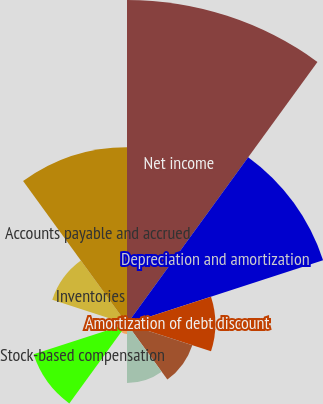Convert chart. <chart><loc_0><loc_0><loc_500><loc_500><pie_chart><fcel>Net income<fcel>Depreciation and amortization<fcel>Amortization of debt discount<fcel>Acquisition-related items<fcel>Provision for doubtful<fcel>Deferred income taxes<fcel>Stock-based compensation<fcel>Accounts receivable net<fcel>Inventories<fcel>Accounts payable and accrued<nl><fcel>29.2%<fcel>18.58%<fcel>7.96%<fcel>6.19%<fcel>5.31%<fcel>0.89%<fcel>8.85%<fcel>0.0%<fcel>7.08%<fcel>15.93%<nl></chart> 